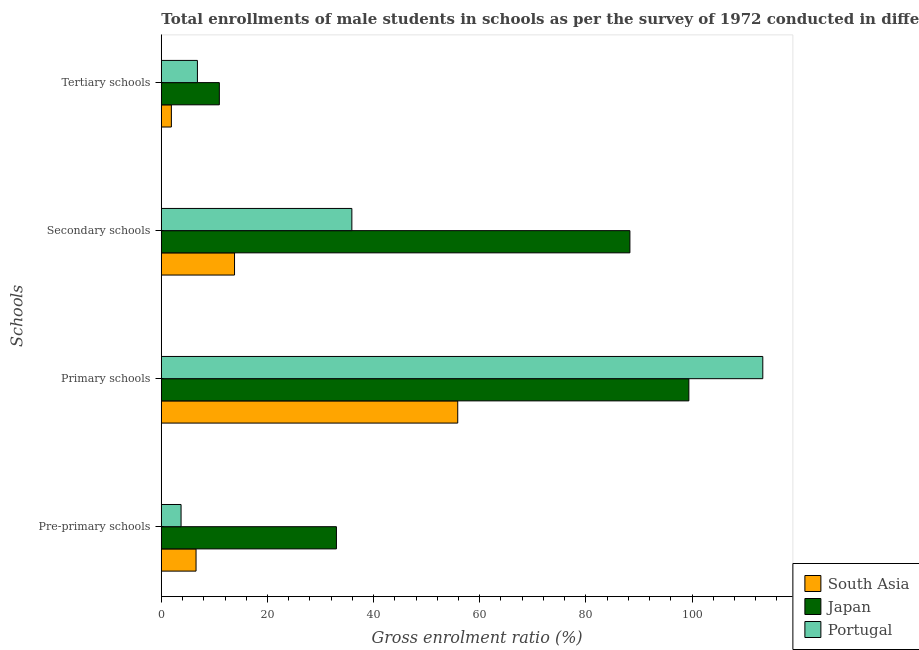Are the number of bars per tick equal to the number of legend labels?
Make the answer very short. Yes. How many bars are there on the 2nd tick from the top?
Make the answer very short. 3. How many bars are there on the 3rd tick from the bottom?
Keep it short and to the point. 3. What is the label of the 4th group of bars from the top?
Your response must be concise. Pre-primary schools. What is the gross enrolment ratio(male) in pre-primary schools in Portugal?
Provide a short and direct response. 3.72. Across all countries, what is the maximum gross enrolment ratio(male) in primary schools?
Ensure brevity in your answer.  113.33. Across all countries, what is the minimum gross enrolment ratio(male) in secondary schools?
Give a very brief answer. 13.79. In which country was the gross enrolment ratio(male) in primary schools maximum?
Give a very brief answer. Portugal. What is the total gross enrolment ratio(male) in primary schools in the graph?
Make the answer very short. 268.59. What is the difference between the gross enrolment ratio(male) in secondary schools in Japan and that in Portugal?
Keep it short and to the point. 52.39. What is the difference between the gross enrolment ratio(male) in pre-primary schools in Portugal and the gross enrolment ratio(male) in tertiary schools in South Asia?
Offer a very short reply. 1.83. What is the average gross enrolment ratio(male) in pre-primary schools per country?
Your response must be concise. 14.42. What is the difference between the gross enrolment ratio(male) in secondary schools and gross enrolment ratio(male) in pre-primary schools in Japan?
Ensure brevity in your answer.  55.3. In how many countries, is the gross enrolment ratio(male) in secondary schools greater than 88 %?
Keep it short and to the point. 1. What is the ratio of the gross enrolment ratio(male) in secondary schools in South Asia to that in Portugal?
Make the answer very short. 0.38. What is the difference between the highest and the second highest gross enrolment ratio(male) in tertiary schools?
Your answer should be very brief. 4.13. What is the difference between the highest and the lowest gross enrolment ratio(male) in primary schools?
Your answer should be very brief. 57.48. In how many countries, is the gross enrolment ratio(male) in pre-primary schools greater than the average gross enrolment ratio(male) in pre-primary schools taken over all countries?
Offer a terse response. 1. Is the sum of the gross enrolment ratio(male) in pre-primary schools in Portugal and Japan greater than the maximum gross enrolment ratio(male) in primary schools across all countries?
Provide a short and direct response. No. Is it the case that in every country, the sum of the gross enrolment ratio(male) in tertiary schools and gross enrolment ratio(male) in primary schools is greater than the sum of gross enrolment ratio(male) in pre-primary schools and gross enrolment ratio(male) in secondary schools?
Your response must be concise. No. Is it the case that in every country, the sum of the gross enrolment ratio(male) in pre-primary schools and gross enrolment ratio(male) in primary schools is greater than the gross enrolment ratio(male) in secondary schools?
Ensure brevity in your answer.  Yes. How many countries are there in the graph?
Offer a terse response. 3. What is the difference between two consecutive major ticks on the X-axis?
Offer a terse response. 20. Are the values on the major ticks of X-axis written in scientific E-notation?
Offer a terse response. No. Does the graph contain any zero values?
Your answer should be very brief. No. Does the graph contain grids?
Make the answer very short. No. Where does the legend appear in the graph?
Offer a terse response. Bottom right. What is the title of the graph?
Provide a short and direct response. Total enrollments of male students in schools as per the survey of 1972 conducted in different countries. Does "Bermuda" appear as one of the legend labels in the graph?
Keep it short and to the point. No. What is the label or title of the Y-axis?
Give a very brief answer. Schools. What is the Gross enrolment ratio (%) of South Asia in Pre-primary schools?
Offer a terse response. 6.54. What is the Gross enrolment ratio (%) of Japan in Pre-primary schools?
Give a very brief answer. 33. What is the Gross enrolment ratio (%) in Portugal in Pre-primary schools?
Your answer should be very brief. 3.72. What is the Gross enrolment ratio (%) of South Asia in Primary schools?
Make the answer very short. 55.85. What is the Gross enrolment ratio (%) in Japan in Primary schools?
Keep it short and to the point. 99.4. What is the Gross enrolment ratio (%) of Portugal in Primary schools?
Provide a short and direct response. 113.33. What is the Gross enrolment ratio (%) of South Asia in Secondary schools?
Ensure brevity in your answer.  13.79. What is the Gross enrolment ratio (%) in Japan in Secondary schools?
Offer a very short reply. 88.29. What is the Gross enrolment ratio (%) in Portugal in Secondary schools?
Your answer should be very brief. 35.9. What is the Gross enrolment ratio (%) of South Asia in Tertiary schools?
Offer a terse response. 1.89. What is the Gross enrolment ratio (%) of Japan in Tertiary schools?
Your answer should be compact. 10.93. What is the Gross enrolment ratio (%) of Portugal in Tertiary schools?
Your answer should be compact. 6.8. Across all Schools, what is the maximum Gross enrolment ratio (%) in South Asia?
Provide a short and direct response. 55.85. Across all Schools, what is the maximum Gross enrolment ratio (%) in Japan?
Offer a very short reply. 99.4. Across all Schools, what is the maximum Gross enrolment ratio (%) of Portugal?
Ensure brevity in your answer.  113.33. Across all Schools, what is the minimum Gross enrolment ratio (%) of South Asia?
Ensure brevity in your answer.  1.89. Across all Schools, what is the minimum Gross enrolment ratio (%) in Japan?
Offer a terse response. 10.93. Across all Schools, what is the minimum Gross enrolment ratio (%) in Portugal?
Give a very brief answer. 3.72. What is the total Gross enrolment ratio (%) in South Asia in the graph?
Your answer should be very brief. 78.09. What is the total Gross enrolment ratio (%) of Japan in the graph?
Keep it short and to the point. 231.63. What is the total Gross enrolment ratio (%) of Portugal in the graph?
Offer a terse response. 159.76. What is the difference between the Gross enrolment ratio (%) in South Asia in Pre-primary schools and that in Primary schools?
Offer a terse response. -49.31. What is the difference between the Gross enrolment ratio (%) of Japan in Pre-primary schools and that in Primary schools?
Ensure brevity in your answer.  -66.41. What is the difference between the Gross enrolment ratio (%) in Portugal in Pre-primary schools and that in Primary schools?
Offer a terse response. -109.61. What is the difference between the Gross enrolment ratio (%) in South Asia in Pre-primary schools and that in Secondary schools?
Keep it short and to the point. -7.25. What is the difference between the Gross enrolment ratio (%) of Japan in Pre-primary schools and that in Secondary schools?
Offer a terse response. -55.3. What is the difference between the Gross enrolment ratio (%) in Portugal in Pre-primary schools and that in Secondary schools?
Your answer should be compact. -32.18. What is the difference between the Gross enrolment ratio (%) of South Asia in Pre-primary schools and that in Tertiary schools?
Your answer should be very brief. 4.65. What is the difference between the Gross enrolment ratio (%) in Japan in Pre-primary schools and that in Tertiary schools?
Your answer should be compact. 22.06. What is the difference between the Gross enrolment ratio (%) of Portugal in Pre-primary schools and that in Tertiary schools?
Provide a succinct answer. -3.08. What is the difference between the Gross enrolment ratio (%) in South Asia in Primary schools and that in Secondary schools?
Ensure brevity in your answer.  42.06. What is the difference between the Gross enrolment ratio (%) in Japan in Primary schools and that in Secondary schools?
Give a very brief answer. 11.11. What is the difference between the Gross enrolment ratio (%) in Portugal in Primary schools and that in Secondary schools?
Your response must be concise. 77.43. What is the difference between the Gross enrolment ratio (%) in South Asia in Primary schools and that in Tertiary schools?
Your response must be concise. 53.96. What is the difference between the Gross enrolment ratio (%) of Japan in Primary schools and that in Tertiary schools?
Your response must be concise. 88.47. What is the difference between the Gross enrolment ratio (%) in Portugal in Primary schools and that in Tertiary schools?
Keep it short and to the point. 106.53. What is the difference between the Gross enrolment ratio (%) in South Asia in Secondary schools and that in Tertiary schools?
Provide a short and direct response. 11.9. What is the difference between the Gross enrolment ratio (%) in Japan in Secondary schools and that in Tertiary schools?
Offer a terse response. 77.36. What is the difference between the Gross enrolment ratio (%) of Portugal in Secondary schools and that in Tertiary schools?
Your answer should be compact. 29.1. What is the difference between the Gross enrolment ratio (%) in South Asia in Pre-primary schools and the Gross enrolment ratio (%) in Japan in Primary schools?
Offer a very short reply. -92.86. What is the difference between the Gross enrolment ratio (%) of South Asia in Pre-primary schools and the Gross enrolment ratio (%) of Portugal in Primary schools?
Keep it short and to the point. -106.79. What is the difference between the Gross enrolment ratio (%) in Japan in Pre-primary schools and the Gross enrolment ratio (%) in Portugal in Primary schools?
Your answer should be very brief. -80.34. What is the difference between the Gross enrolment ratio (%) of South Asia in Pre-primary schools and the Gross enrolment ratio (%) of Japan in Secondary schools?
Provide a succinct answer. -81.75. What is the difference between the Gross enrolment ratio (%) of South Asia in Pre-primary schools and the Gross enrolment ratio (%) of Portugal in Secondary schools?
Give a very brief answer. -29.36. What is the difference between the Gross enrolment ratio (%) of Japan in Pre-primary schools and the Gross enrolment ratio (%) of Portugal in Secondary schools?
Ensure brevity in your answer.  -2.91. What is the difference between the Gross enrolment ratio (%) in South Asia in Pre-primary schools and the Gross enrolment ratio (%) in Japan in Tertiary schools?
Keep it short and to the point. -4.39. What is the difference between the Gross enrolment ratio (%) of South Asia in Pre-primary schools and the Gross enrolment ratio (%) of Portugal in Tertiary schools?
Provide a short and direct response. -0.26. What is the difference between the Gross enrolment ratio (%) of Japan in Pre-primary schools and the Gross enrolment ratio (%) of Portugal in Tertiary schools?
Ensure brevity in your answer.  26.19. What is the difference between the Gross enrolment ratio (%) in South Asia in Primary schools and the Gross enrolment ratio (%) in Japan in Secondary schools?
Provide a succinct answer. -32.44. What is the difference between the Gross enrolment ratio (%) in South Asia in Primary schools and the Gross enrolment ratio (%) in Portugal in Secondary schools?
Ensure brevity in your answer.  19.95. What is the difference between the Gross enrolment ratio (%) of Japan in Primary schools and the Gross enrolment ratio (%) of Portugal in Secondary schools?
Make the answer very short. 63.5. What is the difference between the Gross enrolment ratio (%) in South Asia in Primary schools and the Gross enrolment ratio (%) in Japan in Tertiary schools?
Offer a terse response. 44.92. What is the difference between the Gross enrolment ratio (%) of South Asia in Primary schools and the Gross enrolment ratio (%) of Portugal in Tertiary schools?
Offer a very short reply. 49.05. What is the difference between the Gross enrolment ratio (%) in Japan in Primary schools and the Gross enrolment ratio (%) in Portugal in Tertiary schools?
Offer a terse response. 92.6. What is the difference between the Gross enrolment ratio (%) of South Asia in Secondary schools and the Gross enrolment ratio (%) of Japan in Tertiary schools?
Your response must be concise. 2.86. What is the difference between the Gross enrolment ratio (%) of South Asia in Secondary schools and the Gross enrolment ratio (%) of Portugal in Tertiary schools?
Ensure brevity in your answer.  6.99. What is the difference between the Gross enrolment ratio (%) in Japan in Secondary schools and the Gross enrolment ratio (%) in Portugal in Tertiary schools?
Offer a very short reply. 81.49. What is the average Gross enrolment ratio (%) of South Asia per Schools?
Provide a short and direct response. 19.52. What is the average Gross enrolment ratio (%) in Japan per Schools?
Offer a terse response. 57.91. What is the average Gross enrolment ratio (%) of Portugal per Schools?
Offer a very short reply. 39.94. What is the difference between the Gross enrolment ratio (%) in South Asia and Gross enrolment ratio (%) in Japan in Pre-primary schools?
Keep it short and to the point. -26.45. What is the difference between the Gross enrolment ratio (%) of South Asia and Gross enrolment ratio (%) of Portugal in Pre-primary schools?
Offer a terse response. 2.82. What is the difference between the Gross enrolment ratio (%) of Japan and Gross enrolment ratio (%) of Portugal in Pre-primary schools?
Ensure brevity in your answer.  29.27. What is the difference between the Gross enrolment ratio (%) of South Asia and Gross enrolment ratio (%) of Japan in Primary schools?
Your answer should be very brief. -43.55. What is the difference between the Gross enrolment ratio (%) of South Asia and Gross enrolment ratio (%) of Portugal in Primary schools?
Make the answer very short. -57.48. What is the difference between the Gross enrolment ratio (%) of Japan and Gross enrolment ratio (%) of Portugal in Primary schools?
Your response must be concise. -13.93. What is the difference between the Gross enrolment ratio (%) of South Asia and Gross enrolment ratio (%) of Japan in Secondary schools?
Your answer should be compact. -74.5. What is the difference between the Gross enrolment ratio (%) in South Asia and Gross enrolment ratio (%) in Portugal in Secondary schools?
Provide a succinct answer. -22.11. What is the difference between the Gross enrolment ratio (%) in Japan and Gross enrolment ratio (%) in Portugal in Secondary schools?
Your answer should be very brief. 52.39. What is the difference between the Gross enrolment ratio (%) in South Asia and Gross enrolment ratio (%) in Japan in Tertiary schools?
Your answer should be compact. -9.04. What is the difference between the Gross enrolment ratio (%) in South Asia and Gross enrolment ratio (%) in Portugal in Tertiary schools?
Ensure brevity in your answer.  -4.91. What is the difference between the Gross enrolment ratio (%) of Japan and Gross enrolment ratio (%) of Portugal in Tertiary schools?
Your answer should be compact. 4.13. What is the ratio of the Gross enrolment ratio (%) of South Asia in Pre-primary schools to that in Primary schools?
Your answer should be compact. 0.12. What is the ratio of the Gross enrolment ratio (%) of Japan in Pre-primary schools to that in Primary schools?
Provide a short and direct response. 0.33. What is the ratio of the Gross enrolment ratio (%) of Portugal in Pre-primary schools to that in Primary schools?
Offer a very short reply. 0.03. What is the ratio of the Gross enrolment ratio (%) in South Asia in Pre-primary schools to that in Secondary schools?
Provide a short and direct response. 0.47. What is the ratio of the Gross enrolment ratio (%) in Japan in Pre-primary schools to that in Secondary schools?
Provide a succinct answer. 0.37. What is the ratio of the Gross enrolment ratio (%) of Portugal in Pre-primary schools to that in Secondary schools?
Give a very brief answer. 0.1. What is the ratio of the Gross enrolment ratio (%) in South Asia in Pre-primary schools to that in Tertiary schools?
Your response must be concise. 3.45. What is the ratio of the Gross enrolment ratio (%) of Japan in Pre-primary schools to that in Tertiary schools?
Provide a succinct answer. 3.02. What is the ratio of the Gross enrolment ratio (%) in Portugal in Pre-primary schools to that in Tertiary schools?
Provide a succinct answer. 0.55. What is the ratio of the Gross enrolment ratio (%) in South Asia in Primary schools to that in Secondary schools?
Offer a very short reply. 4.05. What is the ratio of the Gross enrolment ratio (%) in Japan in Primary schools to that in Secondary schools?
Provide a short and direct response. 1.13. What is the ratio of the Gross enrolment ratio (%) in Portugal in Primary schools to that in Secondary schools?
Ensure brevity in your answer.  3.16. What is the ratio of the Gross enrolment ratio (%) in South Asia in Primary schools to that in Tertiary schools?
Offer a terse response. 29.48. What is the ratio of the Gross enrolment ratio (%) in Japan in Primary schools to that in Tertiary schools?
Offer a very short reply. 9.09. What is the ratio of the Gross enrolment ratio (%) in Portugal in Primary schools to that in Tertiary schools?
Your answer should be compact. 16.66. What is the ratio of the Gross enrolment ratio (%) of South Asia in Secondary schools to that in Tertiary schools?
Offer a very short reply. 7.28. What is the ratio of the Gross enrolment ratio (%) of Japan in Secondary schools to that in Tertiary schools?
Keep it short and to the point. 8.08. What is the ratio of the Gross enrolment ratio (%) of Portugal in Secondary schools to that in Tertiary schools?
Offer a very short reply. 5.28. What is the difference between the highest and the second highest Gross enrolment ratio (%) of South Asia?
Give a very brief answer. 42.06. What is the difference between the highest and the second highest Gross enrolment ratio (%) in Japan?
Ensure brevity in your answer.  11.11. What is the difference between the highest and the second highest Gross enrolment ratio (%) in Portugal?
Make the answer very short. 77.43. What is the difference between the highest and the lowest Gross enrolment ratio (%) of South Asia?
Give a very brief answer. 53.96. What is the difference between the highest and the lowest Gross enrolment ratio (%) of Japan?
Your response must be concise. 88.47. What is the difference between the highest and the lowest Gross enrolment ratio (%) of Portugal?
Offer a terse response. 109.61. 